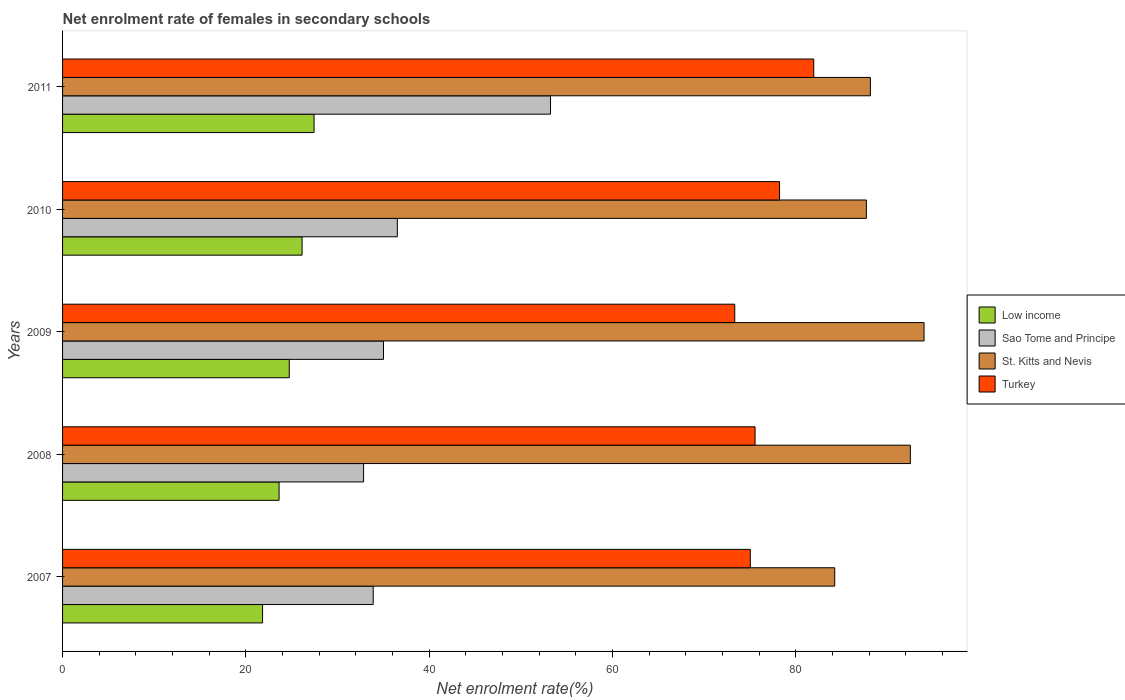How many groups of bars are there?
Your response must be concise. 5. Are the number of bars per tick equal to the number of legend labels?
Your response must be concise. Yes. Are the number of bars on each tick of the Y-axis equal?
Offer a very short reply. Yes. How many bars are there on the 1st tick from the bottom?
Your response must be concise. 4. In how many cases, is the number of bars for a given year not equal to the number of legend labels?
Provide a short and direct response. 0. What is the net enrolment rate of females in secondary schools in St. Kitts and Nevis in 2010?
Give a very brief answer. 87.69. Across all years, what is the maximum net enrolment rate of females in secondary schools in Sao Tome and Principe?
Give a very brief answer. 53.23. Across all years, what is the minimum net enrolment rate of females in secondary schools in Sao Tome and Principe?
Provide a succinct answer. 32.84. What is the total net enrolment rate of females in secondary schools in Sao Tome and Principe in the graph?
Keep it short and to the point. 191.49. What is the difference between the net enrolment rate of females in secondary schools in Low income in 2008 and that in 2010?
Offer a terse response. -2.51. What is the difference between the net enrolment rate of females in secondary schools in Low income in 2009 and the net enrolment rate of females in secondary schools in St. Kitts and Nevis in 2007?
Provide a succinct answer. -59.51. What is the average net enrolment rate of females in secondary schools in Turkey per year?
Provide a short and direct response. 76.81. In the year 2008, what is the difference between the net enrolment rate of females in secondary schools in Sao Tome and Principe and net enrolment rate of females in secondary schools in Turkey?
Offer a terse response. -42.71. What is the ratio of the net enrolment rate of females in secondary schools in St. Kitts and Nevis in 2008 to that in 2011?
Make the answer very short. 1.05. Is the net enrolment rate of females in secondary schools in Sao Tome and Principe in 2010 less than that in 2011?
Ensure brevity in your answer.  Yes. What is the difference between the highest and the second highest net enrolment rate of females in secondary schools in Low income?
Offer a very short reply. 1.31. What is the difference between the highest and the lowest net enrolment rate of females in secondary schools in Sao Tome and Principe?
Your answer should be very brief. 20.4. What does the 3rd bar from the bottom in 2010 represents?
Provide a short and direct response. St. Kitts and Nevis. How many bars are there?
Give a very brief answer. 20. Are all the bars in the graph horizontal?
Offer a very short reply. Yes. How many years are there in the graph?
Keep it short and to the point. 5. What is the difference between two consecutive major ticks on the X-axis?
Make the answer very short. 20. Does the graph contain any zero values?
Give a very brief answer. No. Where does the legend appear in the graph?
Ensure brevity in your answer.  Center right. How many legend labels are there?
Your answer should be compact. 4. How are the legend labels stacked?
Offer a very short reply. Vertical. What is the title of the graph?
Make the answer very short. Net enrolment rate of females in secondary schools. Does "Norway" appear as one of the legend labels in the graph?
Your answer should be very brief. No. What is the label or title of the X-axis?
Offer a terse response. Net enrolment rate(%). What is the Net enrolment rate(%) in Low income in 2007?
Your answer should be compact. 21.82. What is the Net enrolment rate(%) in Sao Tome and Principe in 2007?
Make the answer very short. 33.89. What is the Net enrolment rate(%) in St. Kitts and Nevis in 2007?
Make the answer very short. 84.24. What is the Net enrolment rate(%) in Turkey in 2007?
Provide a succinct answer. 75.03. What is the Net enrolment rate(%) in Low income in 2008?
Ensure brevity in your answer.  23.62. What is the Net enrolment rate(%) in Sao Tome and Principe in 2008?
Provide a short and direct response. 32.84. What is the Net enrolment rate(%) in St. Kitts and Nevis in 2008?
Provide a succinct answer. 92.49. What is the Net enrolment rate(%) in Turkey in 2008?
Ensure brevity in your answer.  75.55. What is the Net enrolment rate(%) of Low income in 2009?
Provide a succinct answer. 24.73. What is the Net enrolment rate(%) in Sao Tome and Principe in 2009?
Make the answer very short. 35.01. What is the Net enrolment rate(%) of St. Kitts and Nevis in 2009?
Keep it short and to the point. 93.98. What is the Net enrolment rate(%) of Turkey in 2009?
Offer a terse response. 73.33. What is the Net enrolment rate(%) of Low income in 2010?
Offer a very short reply. 26.13. What is the Net enrolment rate(%) in Sao Tome and Principe in 2010?
Offer a terse response. 36.52. What is the Net enrolment rate(%) of St. Kitts and Nevis in 2010?
Your answer should be compact. 87.69. What is the Net enrolment rate(%) in Turkey in 2010?
Make the answer very short. 78.22. What is the Net enrolment rate(%) of Low income in 2011?
Your answer should be very brief. 27.44. What is the Net enrolment rate(%) in Sao Tome and Principe in 2011?
Keep it short and to the point. 53.23. What is the Net enrolment rate(%) in St. Kitts and Nevis in 2011?
Give a very brief answer. 88.13. What is the Net enrolment rate(%) of Turkey in 2011?
Provide a short and direct response. 81.95. Across all years, what is the maximum Net enrolment rate(%) of Low income?
Give a very brief answer. 27.44. Across all years, what is the maximum Net enrolment rate(%) in Sao Tome and Principe?
Your answer should be compact. 53.23. Across all years, what is the maximum Net enrolment rate(%) in St. Kitts and Nevis?
Your response must be concise. 93.98. Across all years, what is the maximum Net enrolment rate(%) in Turkey?
Your answer should be compact. 81.95. Across all years, what is the minimum Net enrolment rate(%) in Low income?
Offer a terse response. 21.82. Across all years, what is the minimum Net enrolment rate(%) of Sao Tome and Principe?
Your response must be concise. 32.84. Across all years, what is the minimum Net enrolment rate(%) of St. Kitts and Nevis?
Offer a very short reply. 84.24. Across all years, what is the minimum Net enrolment rate(%) of Turkey?
Your response must be concise. 73.33. What is the total Net enrolment rate(%) of Low income in the graph?
Make the answer very short. 123.73. What is the total Net enrolment rate(%) of Sao Tome and Principe in the graph?
Provide a succinct answer. 191.49. What is the total Net enrolment rate(%) in St. Kitts and Nevis in the graph?
Your answer should be compact. 446.52. What is the total Net enrolment rate(%) in Turkey in the graph?
Offer a very short reply. 384.06. What is the difference between the Net enrolment rate(%) of Low income in 2007 and that in 2008?
Provide a short and direct response. -1.8. What is the difference between the Net enrolment rate(%) of Sao Tome and Principe in 2007 and that in 2008?
Your answer should be very brief. 1.05. What is the difference between the Net enrolment rate(%) of St. Kitts and Nevis in 2007 and that in 2008?
Provide a succinct answer. -8.25. What is the difference between the Net enrolment rate(%) of Turkey in 2007 and that in 2008?
Offer a terse response. -0.52. What is the difference between the Net enrolment rate(%) of Low income in 2007 and that in 2009?
Keep it short and to the point. -2.91. What is the difference between the Net enrolment rate(%) in Sao Tome and Principe in 2007 and that in 2009?
Ensure brevity in your answer.  -1.12. What is the difference between the Net enrolment rate(%) in St. Kitts and Nevis in 2007 and that in 2009?
Give a very brief answer. -9.74. What is the difference between the Net enrolment rate(%) of Turkey in 2007 and that in 2009?
Your answer should be very brief. 1.7. What is the difference between the Net enrolment rate(%) of Low income in 2007 and that in 2010?
Make the answer very short. -4.31. What is the difference between the Net enrolment rate(%) of Sao Tome and Principe in 2007 and that in 2010?
Provide a short and direct response. -2.63. What is the difference between the Net enrolment rate(%) in St. Kitts and Nevis in 2007 and that in 2010?
Your response must be concise. -3.45. What is the difference between the Net enrolment rate(%) in Turkey in 2007 and that in 2010?
Your answer should be very brief. -3.19. What is the difference between the Net enrolment rate(%) of Low income in 2007 and that in 2011?
Ensure brevity in your answer.  -5.62. What is the difference between the Net enrolment rate(%) of Sao Tome and Principe in 2007 and that in 2011?
Offer a very short reply. -19.35. What is the difference between the Net enrolment rate(%) in St. Kitts and Nevis in 2007 and that in 2011?
Offer a terse response. -3.89. What is the difference between the Net enrolment rate(%) in Turkey in 2007 and that in 2011?
Ensure brevity in your answer.  -6.92. What is the difference between the Net enrolment rate(%) of Low income in 2008 and that in 2009?
Offer a very short reply. -1.11. What is the difference between the Net enrolment rate(%) in Sao Tome and Principe in 2008 and that in 2009?
Offer a terse response. -2.17. What is the difference between the Net enrolment rate(%) in St. Kitts and Nevis in 2008 and that in 2009?
Your response must be concise. -1.49. What is the difference between the Net enrolment rate(%) of Turkey in 2008 and that in 2009?
Your answer should be very brief. 2.22. What is the difference between the Net enrolment rate(%) of Low income in 2008 and that in 2010?
Provide a succinct answer. -2.51. What is the difference between the Net enrolment rate(%) of Sao Tome and Principe in 2008 and that in 2010?
Offer a very short reply. -3.68. What is the difference between the Net enrolment rate(%) in St. Kitts and Nevis in 2008 and that in 2010?
Your answer should be compact. 4.8. What is the difference between the Net enrolment rate(%) of Turkey in 2008 and that in 2010?
Provide a short and direct response. -2.67. What is the difference between the Net enrolment rate(%) of Low income in 2008 and that in 2011?
Offer a terse response. -3.82. What is the difference between the Net enrolment rate(%) of Sao Tome and Principe in 2008 and that in 2011?
Make the answer very short. -20.4. What is the difference between the Net enrolment rate(%) in St. Kitts and Nevis in 2008 and that in 2011?
Offer a terse response. 4.36. What is the difference between the Net enrolment rate(%) in Turkey in 2008 and that in 2011?
Your answer should be compact. -6.4. What is the difference between the Net enrolment rate(%) of Low income in 2009 and that in 2010?
Make the answer very short. -1.4. What is the difference between the Net enrolment rate(%) of Sao Tome and Principe in 2009 and that in 2010?
Offer a very short reply. -1.51. What is the difference between the Net enrolment rate(%) of St. Kitts and Nevis in 2009 and that in 2010?
Provide a succinct answer. 6.29. What is the difference between the Net enrolment rate(%) in Turkey in 2009 and that in 2010?
Provide a succinct answer. -4.89. What is the difference between the Net enrolment rate(%) of Low income in 2009 and that in 2011?
Provide a short and direct response. -2.71. What is the difference between the Net enrolment rate(%) of Sao Tome and Principe in 2009 and that in 2011?
Give a very brief answer. -18.22. What is the difference between the Net enrolment rate(%) of St. Kitts and Nevis in 2009 and that in 2011?
Provide a short and direct response. 5.85. What is the difference between the Net enrolment rate(%) of Turkey in 2009 and that in 2011?
Keep it short and to the point. -8.62. What is the difference between the Net enrolment rate(%) in Low income in 2010 and that in 2011?
Provide a succinct answer. -1.31. What is the difference between the Net enrolment rate(%) in Sao Tome and Principe in 2010 and that in 2011?
Your answer should be compact. -16.71. What is the difference between the Net enrolment rate(%) in St. Kitts and Nevis in 2010 and that in 2011?
Give a very brief answer. -0.44. What is the difference between the Net enrolment rate(%) of Turkey in 2010 and that in 2011?
Keep it short and to the point. -3.73. What is the difference between the Net enrolment rate(%) in Low income in 2007 and the Net enrolment rate(%) in Sao Tome and Principe in 2008?
Make the answer very short. -11.02. What is the difference between the Net enrolment rate(%) in Low income in 2007 and the Net enrolment rate(%) in St. Kitts and Nevis in 2008?
Ensure brevity in your answer.  -70.67. What is the difference between the Net enrolment rate(%) of Low income in 2007 and the Net enrolment rate(%) of Turkey in 2008?
Provide a short and direct response. -53.73. What is the difference between the Net enrolment rate(%) of Sao Tome and Principe in 2007 and the Net enrolment rate(%) of St. Kitts and Nevis in 2008?
Your answer should be very brief. -58.6. What is the difference between the Net enrolment rate(%) in Sao Tome and Principe in 2007 and the Net enrolment rate(%) in Turkey in 2008?
Make the answer very short. -41.66. What is the difference between the Net enrolment rate(%) in St. Kitts and Nevis in 2007 and the Net enrolment rate(%) in Turkey in 2008?
Your answer should be compact. 8.69. What is the difference between the Net enrolment rate(%) of Low income in 2007 and the Net enrolment rate(%) of Sao Tome and Principe in 2009?
Offer a very short reply. -13.19. What is the difference between the Net enrolment rate(%) in Low income in 2007 and the Net enrolment rate(%) in St. Kitts and Nevis in 2009?
Your answer should be very brief. -72.16. What is the difference between the Net enrolment rate(%) in Low income in 2007 and the Net enrolment rate(%) in Turkey in 2009?
Your answer should be very brief. -51.51. What is the difference between the Net enrolment rate(%) of Sao Tome and Principe in 2007 and the Net enrolment rate(%) of St. Kitts and Nevis in 2009?
Make the answer very short. -60.09. What is the difference between the Net enrolment rate(%) in Sao Tome and Principe in 2007 and the Net enrolment rate(%) in Turkey in 2009?
Your response must be concise. -39.44. What is the difference between the Net enrolment rate(%) of St. Kitts and Nevis in 2007 and the Net enrolment rate(%) of Turkey in 2009?
Keep it short and to the point. 10.91. What is the difference between the Net enrolment rate(%) in Low income in 2007 and the Net enrolment rate(%) in Sao Tome and Principe in 2010?
Keep it short and to the point. -14.7. What is the difference between the Net enrolment rate(%) of Low income in 2007 and the Net enrolment rate(%) of St. Kitts and Nevis in 2010?
Your answer should be compact. -65.87. What is the difference between the Net enrolment rate(%) in Low income in 2007 and the Net enrolment rate(%) in Turkey in 2010?
Your answer should be compact. -56.4. What is the difference between the Net enrolment rate(%) in Sao Tome and Principe in 2007 and the Net enrolment rate(%) in St. Kitts and Nevis in 2010?
Make the answer very short. -53.8. What is the difference between the Net enrolment rate(%) of Sao Tome and Principe in 2007 and the Net enrolment rate(%) of Turkey in 2010?
Make the answer very short. -44.33. What is the difference between the Net enrolment rate(%) of St. Kitts and Nevis in 2007 and the Net enrolment rate(%) of Turkey in 2010?
Provide a short and direct response. 6.02. What is the difference between the Net enrolment rate(%) in Low income in 2007 and the Net enrolment rate(%) in Sao Tome and Principe in 2011?
Make the answer very short. -31.42. What is the difference between the Net enrolment rate(%) in Low income in 2007 and the Net enrolment rate(%) in St. Kitts and Nevis in 2011?
Provide a short and direct response. -66.31. What is the difference between the Net enrolment rate(%) in Low income in 2007 and the Net enrolment rate(%) in Turkey in 2011?
Give a very brief answer. -60.13. What is the difference between the Net enrolment rate(%) in Sao Tome and Principe in 2007 and the Net enrolment rate(%) in St. Kitts and Nevis in 2011?
Offer a terse response. -54.24. What is the difference between the Net enrolment rate(%) of Sao Tome and Principe in 2007 and the Net enrolment rate(%) of Turkey in 2011?
Give a very brief answer. -48.06. What is the difference between the Net enrolment rate(%) of St. Kitts and Nevis in 2007 and the Net enrolment rate(%) of Turkey in 2011?
Ensure brevity in your answer.  2.29. What is the difference between the Net enrolment rate(%) of Low income in 2008 and the Net enrolment rate(%) of Sao Tome and Principe in 2009?
Provide a succinct answer. -11.39. What is the difference between the Net enrolment rate(%) of Low income in 2008 and the Net enrolment rate(%) of St. Kitts and Nevis in 2009?
Your response must be concise. -70.36. What is the difference between the Net enrolment rate(%) of Low income in 2008 and the Net enrolment rate(%) of Turkey in 2009?
Your response must be concise. -49.71. What is the difference between the Net enrolment rate(%) of Sao Tome and Principe in 2008 and the Net enrolment rate(%) of St. Kitts and Nevis in 2009?
Provide a succinct answer. -61.14. What is the difference between the Net enrolment rate(%) in Sao Tome and Principe in 2008 and the Net enrolment rate(%) in Turkey in 2009?
Provide a short and direct response. -40.49. What is the difference between the Net enrolment rate(%) of St. Kitts and Nevis in 2008 and the Net enrolment rate(%) of Turkey in 2009?
Make the answer very short. 19.16. What is the difference between the Net enrolment rate(%) of Low income in 2008 and the Net enrolment rate(%) of Sao Tome and Principe in 2010?
Your answer should be very brief. -12.9. What is the difference between the Net enrolment rate(%) in Low income in 2008 and the Net enrolment rate(%) in St. Kitts and Nevis in 2010?
Provide a short and direct response. -64.07. What is the difference between the Net enrolment rate(%) of Low income in 2008 and the Net enrolment rate(%) of Turkey in 2010?
Your response must be concise. -54.6. What is the difference between the Net enrolment rate(%) in Sao Tome and Principe in 2008 and the Net enrolment rate(%) in St. Kitts and Nevis in 2010?
Offer a very short reply. -54.85. What is the difference between the Net enrolment rate(%) of Sao Tome and Principe in 2008 and the Net enrolment rate(%) of Turkey in 2010?
Provide a succinct answer. -45.38. What is the difference between the Net enrolment rate(%) of St. Kitts and Nevis in 2008 and the Net enrolment rate(%) of Turkey in 2010?
Ensure brevity in your answer.  14.27. What is the difference between the Net enrolment rate(%) in Low income in 2008 and the Net enrolment rate(%) in Sao Tome and Principe in 2011?
Offer a very short reply. -29.61. What is the difference between the Net enrolment rate(%) in Low income in 2008 and the Net enrolment rate(%) in St. Kitts and Nevis in 2011?
Offer a terse response. -64.51. What is the difference between the Net enrolment rate(%) in Low income in 2008 and the Net enrolment rate(%) in Turkey in 2011?
Provide a short and direct response. -58.33. What is the difference between the Net enrolment rate(%) of Sao Tome and Principe in 2008 and the Net enrolment rate(%) of St. Kitts and Nevis in 2011?
Give a very brief answer. -55.29. What is the difference between the Net enrolment rate(%) of Sao Tome and Principe in 2008 and the Net enrolment rate(%) of Turkey in 2011?
Ensure brevity in your answer.  -49.11. What is the difference between the Net enrolment rate(%) in St. Kitts and Nevis in 2008 and the Net enrolment rate(%) in Turkey in 2011?
Offer a very short reply. 10.54. What is the difference between the Net enrolment rate(%) in Low income in 2009 and the Net enrolment rate(%) in Sao Tome and Principe in 2010?
Make the answer very short. -11.79. What is the difference between the Net enrolment rate(%) in Low income in 2009 and the Net enrolment rate(%) in St. Kitts and Nevis in 2010?
Ensure brevity in your answer.  -62.96. What is the difference between the Net enrolment rate(%) in Low income in 2009 and the Net enrolment rate(%) in Turkey in 2010?
Provide a short and direct response. -53.49. What is the difference between the Net enrolment rate(%) of Sao Tome and Principe in 2009 and the Net enrolment rate(%) of St. Kitts and Nevis in 2010?
Your response must be concise. -52.68. What is the difference between the Net enrolment rate(%) of Sao Tome and Principe in 2009 and the Net enrolment rate(%) of Turkey in 2010?
Provide a succinct answer. -43.2. What is the difference between the Net enrolment rate(%) of St. Kitts and Nevis in 2009 and the Net enrolment rate(%) of Turkey in 2010?
Keep it short and to the point. 15.76. What is the difference between the Net enrolment rate(%) in Low income in 2009 and the Net enrolment rate(%) in Sao Tome and Principe in 2011?
Your answer should be very brief. -28.5. What is the difference between the Net enrolment rate(%) in Low income in 2009 and the Net enrolment rate(%) in St. Kitts and Nevis in 2011?
Your answer should be very brief. -63.4. What is the difference between the Net enrolment rate(%) of Low income in 2009 and the Net enrolment rate(%) of Turkey in 2011?
Your answer should be very brief. -57.22. What is the difference between the Net enrolment rate(%) in Sao Tome and Principe in 2009 and the Net enrolment rate(%) in St. Kitts and Nevis in 2011?
Keep it short and to the point. -53.12. What is the difference between the Net enrolment rate(%) in Sao Tome and Principe in 2009 and the Net enrolment rate(%) in Turkey in 2011?
Make the answer very short. -46.94. What is the difference between the Net enrolment rate(%) in St. Kitts and Nevis in 2009 and the Net enrolment rate(%) in Turkey in 2011?
Make the answer very short. 12.03. What is the difference between the Net enrolment rate(%) in Low income in 2010 and the Net enrolment rate(%) in Sao Tome and Principe in 2011?
Provide a succinct answer. -27.1. What is the difference between the Net enrolment rate(%) in Low income in 2010 and the Net enrolment rate(%) in St. Kitts and Nevis in 2011?
Your answer should be compact. -62. What is the difference between the Net enrolment rate(%) of Low income in 2010 and the Net enrolment rate(%) of Turkey in 2011?
Offer a very short reply. -55.82. What is the difference between the Net enrolment rate(%) of Sao Tome and Principe in 2010 and the Net enrolment rate(%) of St. Kitts and Nevis in 2011?
Provide a succinct answer. -51.61. What is the difference between the Net enrolment rate(%) in Sao Tome and Principe in 2010 and the Net enrolment rate(%) in Turkey in 2011?
Provide a short and direct response. -45.43. What is the difference between the Net enrolment rate(%) in St. Kitts and Nevis in 2010 and the Net enrolment rate(%) in Turkey in 2011?
Offer a very short reply. 5.74. What is the average Net enrolment rate(%) in Low income per year?
Your answer should be very brief. 24.75. What is the average Net enrolment rate(%) in Sao Tome and Principe per year?
Your answer should be compact. 38.3. What is the average Net enrolment rate(%) of St. Kitts and Nevis per year?
Your answer should be compact. 89.3. What is the average Net enrolment rate(%) of Turkey per year?
Offer a terse response. 76.81. In the year 2007, what is the difference between the Net enrolment rate(%) of Low income and Net enrolment rate(%) of Sao Tome and Principe?
Your answer should be compact. -12.07. In the year 2007, what is the difference between the Net enrolment rate(%) of Low income and Net enrolment rate(%) of St. Kitts and Nevis?
Provide a succinct answer. -62.42. In the year 2007, what is the difference between the Net enrolment rate(%) of Low income and Net enrolment rate(%) of Turkey?
Provide a short and direct response. -53.21. In the year 2007, what is the difference between the Net enrolment rate(%) in Sao Tome and Principe and Net enrolment rate(%) in St. Kitts and Nevis?
Ensure brevity in your answer.  -50.35. In the year 2007, what is the difference between the Net enrolment rate(%) of Sao Tome and Principe and Net enrolment rate(%) of Turkey?
Ensure brevity in your answer.  -41.14. In the year 2007, what is the difference between the Net enrolment rate(%) in St. Kitts and Nevis and Net enrolment rate(%) in Turkey?
Your response must be concise. 9.21. In the year 2008, what is the difference between the Net enrolment rate(%) in Low income and Net enrolment rate(%) in Sao Tome and Principe?
Offer a terse response. -9.22. In the year 2008, what is the difference between the Net enrolment rate(%) of Low income and Net enrolment rate(%) of St. Kitts and Nevis?
Offer a terse response. -68.87. In the year 2008, what is the difference between the Net enrolment rate(%) in Low income and Net enrolment rate(%) in Turkey?
Provide a short and direct response. -51.93. In the year 2008, what is the difference between the Net enrolment rate(%) of Sao Tome and Principe and Net enrolment rate(%) of St. Kitts and Nevis?
Keep it short and to the point. -59.65. In the year 2008, what is the difference between the Net enrolment rate(%) of Sao Tome and Principe and Net enrolment rate(%) of Turkey?
Keep it short and to the point. -42.71. In the year 2008, what is the difference between the Net enrolment rate(%) in St. Kitts and Nevis and Net enrolment rate(%) in Turkey?
Give a very brief answer. 16.94. In the year 2009, what is the difference between the Net enrolment rate(%) in Low income and Net enrolment rate(%) in Sao Tome and Principe?
Offer a very short reply. -10.28. In the year 2009, what is the difference between the Net enrolment rate(%) of Low income and Net enrolment rate(%) of St. Kitts and Nevis?
Make the answer very short. -69.25. In the year 2009, what is the difference between the Net enrolment rate(%) in Low income and Net enrolment rate(%) in Turkey?
Give a very brief answer. -48.6. In the year 2009, what is the difference between the Net enrolment rate(%) of Sao Tome and Principe and Net enrolment rate(%) of St. Kitts and Nevis?
Provide a short and direct response. -58.97. In the year 2009, what is the difference between the Net enrolment rate(%) in Sao Tome and Principe and Net enrolment rate(%) in Turkey?
Offer a terse response. -38.32. In the year 2009, what is the difference between the Net enrolment rate(%) of St. Kitts and Nevis and Net enrolment rate(%) of Turkey?
Offer a very short reply. 20.65. In the year 2010, what is the difference between the Net enrolment rate(%) in Low income and Net enrolment rate(%) in Sao Tome and Principe?
Give a very brief answer. -10.39. In the year 2010, what is the difference between the Net enrolment rate(%) in Low income and Net enrolment rate(%) in St. Kitts and Nevis?
Make the answer very short. -61.56. In the year 2010, what is the difference between the Net enrolment rate(%) of Low income and Net enrolment rate(%) of Turkey?
Provide a succinct answer. -52.09. In the year 2010, what is the difference between the Net enrolment rate(%) of Sao Tome and Principe and Net enrolment rate(%) of St. Kitts and Nevis?
Provide a short and direct response. -51.17. In the year 2010, what is the difference between the Net enrolment rate(%) of Sao Tome and Principe and Net enrolment rate(%) of Turkey?
Your answer should be compact. -41.7. In the year 2010, what is the difference between the Net enrolment rate(%) of St. Kitts and Nevis and Net enrolment rate(%) of Turkey?
Keep it short and to the point. 9.47. In the year 2011, what is the difference between the Net enrolment rate(%) in Low income and Net enrolment rate(%) in Sao Tome and Principe?
Your response must be concise. -25.8. In the year 2011, what is the difference between the Net enrolment rate(%) in Low income and Net enrolment rate(%) in St. Kitts and Nevis?
Make the answer very short. -60.69. In the year 2011, what is the difference between the Net enrolment rate(%) in Low income and Net enrolment rate(%) in Turkey?
Your response must be concise. -54.51. In the year 2011, what is the difference between the Net enrolment rate(%) in Sao Tome and Principe and Net enrolment rate(%) in St. Kitts and Nevis?
Provide a short and direct response. -34.89. In the year 2011, what is the difference between the Net enrolment rate(%) in Sao Tome and Principe and Net enrolment rate(%) in Turkey?
Your answer should be very brief. -28.71. In the year 2011, what is the difference between the Net enrolment rate(%) in St. Kitts and Nevis and Net enrolment rate(%) in Turkey?
Give a very brief answer. 6.18. What is the ratio of the Net enrolment rate(%) of Low income in 2007 to that in 2008?
Your response must be concise. 0.92. What is the ratio of the Net enrolment rate(%) of Sao Tome and Principe in 2007 to that in 2008?
Offer a terse response. 1.03. What is the ratio of the Net enrolment rate(%) of St. Kitts and Nevis in 2007 to that in 2008?
Offer a very short reply. 0.91. What is the ratio of the Net enrolment rate(%) of Turkey in 2007 to that in 2008?
Offer a terse response. 0.99. What is the ratio of the Net enrolment rate(%) of Low income in 2007 to that in 2009?
Offer a terse response. 0.88. What is the ratio of the Net enrolment rate(%) of Sao Tome and Principe in 2007 to that in 2009?
Your response must be concise. 0.97. What is the ratio of the Net enrolment rate(%) in St. Kitts and Nevis in 2007 to that in 2009?
Provide a short and direct response. 0.9. What is the ratio of the Net enrolment rate(%) of Turkey in 2007 to that in 2009?
Give a very brief answer. 1.02. What is the ratio of the Net enrolment rate(%) of Low income in 2007 to that in 2010?
Provide a succinct answer. 0.83. What is the ratio of the Net enrolment rate(%) in Sao Tome and Principe in 2007 to that in 2010?
Your answer should be compact. 0.93. What is the ratio of the Net enrolment rate(%) in St. Kitts and Nevis in 2007 to that in 2010?
Make the answer very short. 0.96. What is the ratio of the Net enrolment rate(%) in Turkey in 2007 to that in 2010?
Ensure brevity in your answer.  0.96. What is the ratio of the Net enrolment rate(%) in Low income in 2007 to that in 2011?
Your answer should be very brief. 0.8. What is the ratio of the Net enrolment rate(%) in Sao Tome and Principe in 2007 to that in 2011?
Your response must be concise. 0.64. What is the ratio of the Net enrolment rate(%) in St. Kitts and Nevis in 2007 to that in 2011?
Keep it short and to the point. 0.96. What is the ratio of the Net enrolment rate(%) of Turkey in 2007 to that in 2011?
Offer a very short reply. 0.92. What is the ratio of the Net enrolment rate(%) in Low income in 2008 to that in 2009?
Offer a very short reply. 0.96. What is the ratio of the Net enrolment rate(%) of Sao Tome and Principe in 2008 to that in 2009?
Make the answer very short. 0.94. What is the ratio of the Net enrolment rate(%) of St. Kitts and Nevis in 2008 to that in 2009?
Provide a succinct answer. 0.98. What is the ratio of the Net enrolment rate(%) of Turkey in 2008 to that in 2009?
Provide a succinct answer. 1.03. What is the ratio of the Net enrolment rate(%) of Low income in 2008 to that in 2010?
Provide a short and direct response. 0.9. What is the ratio of the Net enrolment rate(%) of Sao Tome and Principe in 2008 to that in 2010?
Give a very brief answer. 0.9. What is the ratio of the Net enrolment rate(%) in St. Kitts and Nevis in 2008 to that in 2010?
Offer a terse response. 1.05. What is the ratio of the Net enrolment rate(%) of Turkey in 2008 to that in 2010?
Offer a very short reply. 0.97. What is the ratio of the Net enrolment rate(%) in Low income in 2008 to that in 2011?
Offer a terse response. 0.86. What is the ratio of the Net enrolment rate(%) of Sao Tome and Principe in 2008 to that in 2011?
Keep it short and to the point. 0.62. What is the ratio of the Net enrolment rate(%) of St. Kitts and Nevis in 2008 to that in 2011?
Give a very brief answer. 1.05. What is the ratio of the Net enrolment rate(%) in Turkey in 2008 to that in 2011?
Your response must be concise. 0.92. What is the ratio of the Net enrolment rate(%) in Low income in 2009 to that in 2010?
Your answer should be compact. 0.95. What is the ratio of the Net enrolment rate(%) in Sao Tome and Principe in 2009 to that in 2010?
Provide a short and direct response. 0.96. What is the ratio of the Net enrolment rate(%) in St. Kitts and Nevis in 2009 to that in 2010?
Keep it short and to the point. 1.07. What is the ratio of the Net enrolment rate(%) of Turkey in 2009 to that in 2010?
Your answer should be compact. 0.94. What is the ratio of the Net enrolment rate(%) of Low income in 2009 to that in 2011?
Provide a succinct answer. 0.9. What is the ratio of the Net enrolment rate(%) of Sao Tome and Principe in 2009 to that in 2011?
Provide a short and direct response. 0.66. What is the ratio of the Net enrolment rate(%) in St. Kitts and Nevis in 2009 to that in 2011?
Ensure brevity in your answer.  1.07. What is the ratio of the Net enrolment rate(%) in Turkey in 2009 to that in 2011?
Provide a short and direct response. 0.89. What is the ratio of the Net enrolment rate(%) in Low income in 2010 to that in 2011?
Your answer should be very brief. 0.95. What is the ratio of the Net enrolment rate(%) in Sao Tome and Principe in 2010 to that in 2011?
Your answer should be very brief. 0.69. What is the ratio of the Net enrolment rate(%) of Turkey in 2010 to that in 2011?
Provide a succinct answer. 0.95. What is the difference between the highest and the second highest Net enrolment rate(%) in Low income?
Ensure brevity in your answer.  1.31. What is the difference between the highest and the second highest Net enrolment rate(%) of Sao Tome and Principe?
Ensure brevity in your answer.  16.71. What is the difference between the highest and the second highest Net enrolment rate(%) in St. Kitts and Nevis?
Your answer should be compact. 1.49. What is the difference between the highest and the second highest Net enrolment rate(%) in Turkey?
Provide a short and direct response. 3.73. What is the difference between the highest and the lowest Net enrolment rate(%) of Low income?
Your response must be concise. 5.62. What is the difference between the highest and the lowest Net enrolment rate(%) in Sao Tome and Principe?
Make the answer very short. 20.4. What is the difference between the highest and the lowest Net enrolment rate(%) in St. Kitts and Nevis?
Offer a very short reply. 9.74. What is the difference between the highest and the lowest Net enrolment rate(%) in Turkey?
Provide a short and direct response. 8.62. 